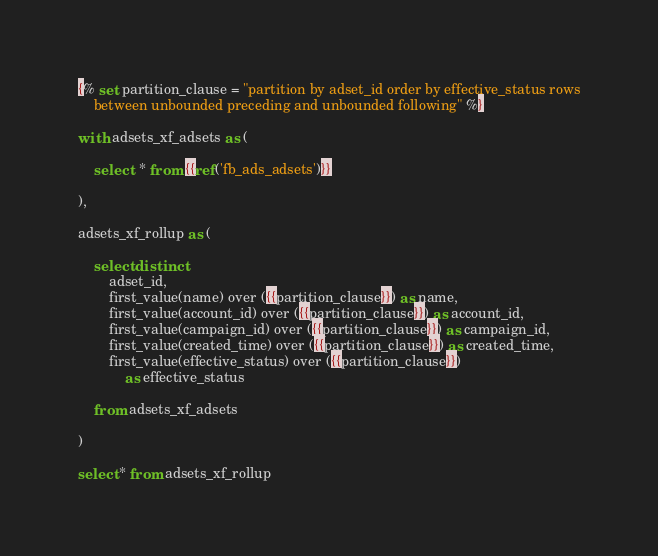Convert code to text. <code><loc_0><loc_0><loc_500><loc_500><_SQL_>{% set partition_clause = "partition by adset_id order by effective_status rows
    between unbounded preceding and unbounded following" %}

with adsets_xf_adsets as (

    select  * from {{ref('fb_ads_adsets')}}

),

adsets_xf_rollup as (

    select distinct
        adset_id,
        first_value(name) over ({{partition_clause}}) as name,
        first_value(account_id) over ({{partition_clause}}) as account_id,
        first_value(campaign_id) over ({{partition_clause}}) as campaign_id,
        first_value(created_time) over ({{partition_clause}}) as created_time,
        first_value(effective_status) over ({{partition_clause}}) 
            as effective_status

    from adsets_xf_adsets

)

select * from adsets_xf_rollup
</code> 